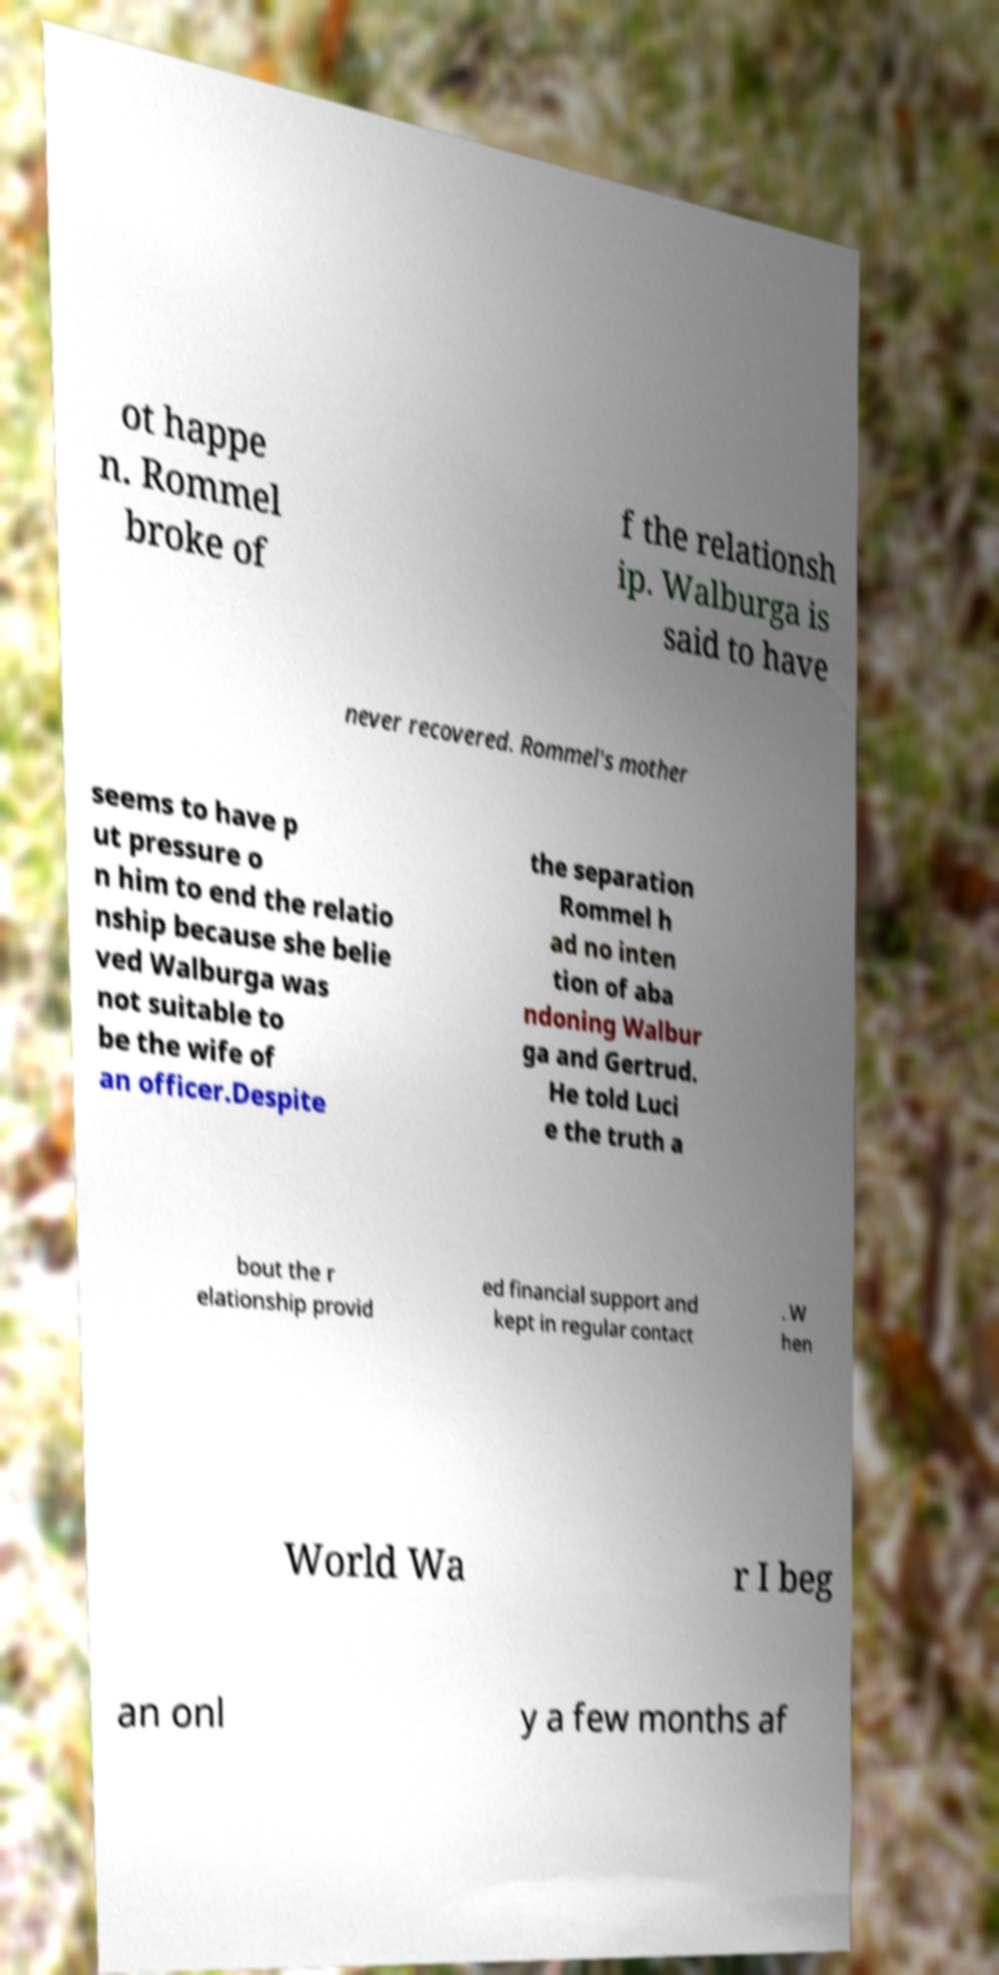I need the written content from this picture converted into text. Can you do that? ot happe n. Rommel broke of f the relationsh ip. Walburga is said to have never recovered. Rommel's mother seems to have p ut pressure o n him to end the relatio nship because she belie ved Walburga was not suitable to be the wife of an officer.Despite the separation Rommel h ad no inten tion of aba ndoning Walbur ga and Gertrud. He told Luci e the truth a bout the r elationship provid ed financial support and kept in regular contact . W hen World Wa r I beg an onl y a few months af 